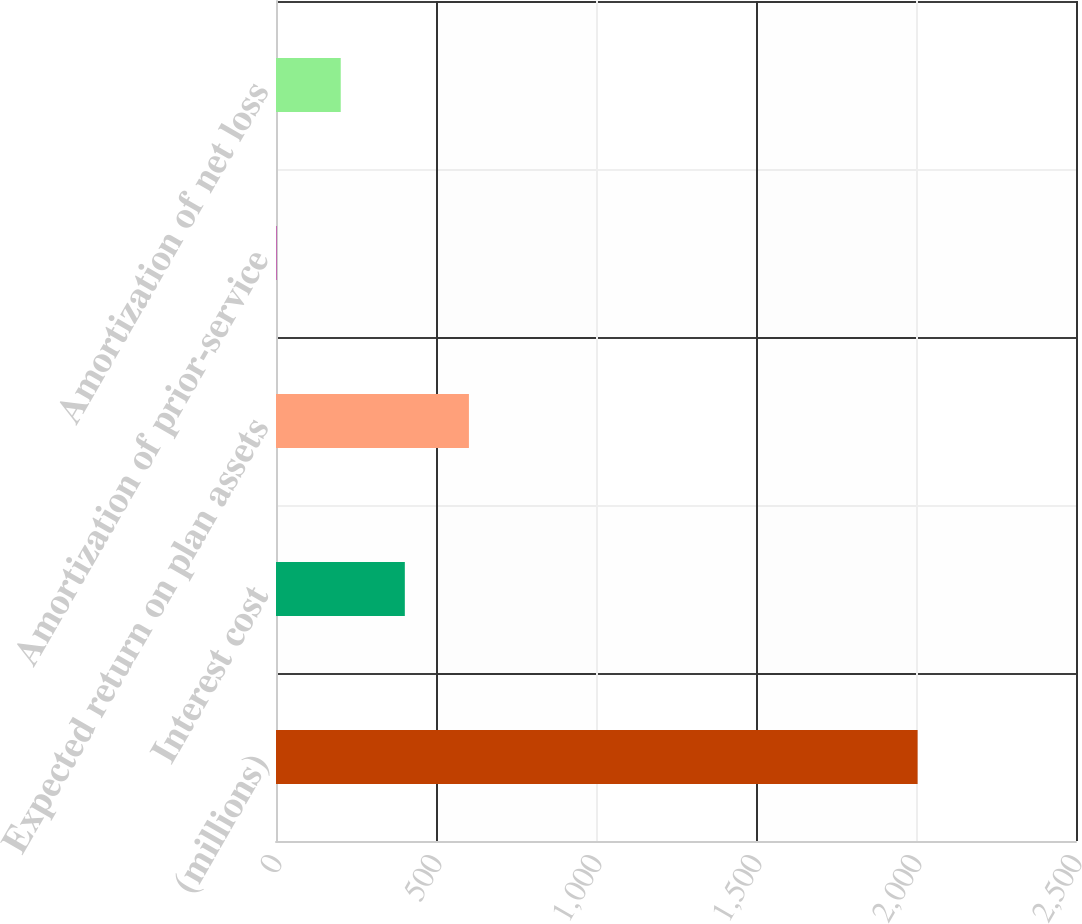Convert chart to OTSL. <chart><loc_0><loc_0><loc_500><loc_500><bar_chart><fcel>(millions)<fcel>Interest cost<fcel>Expected return on plan assets<fcel>Amortization of prior-service<fcel>Amortization of net loss<nl><fcel>2005<fcel>402.6<fcel>602.9<fcel>2<fcel>202.3<nl></chart> 